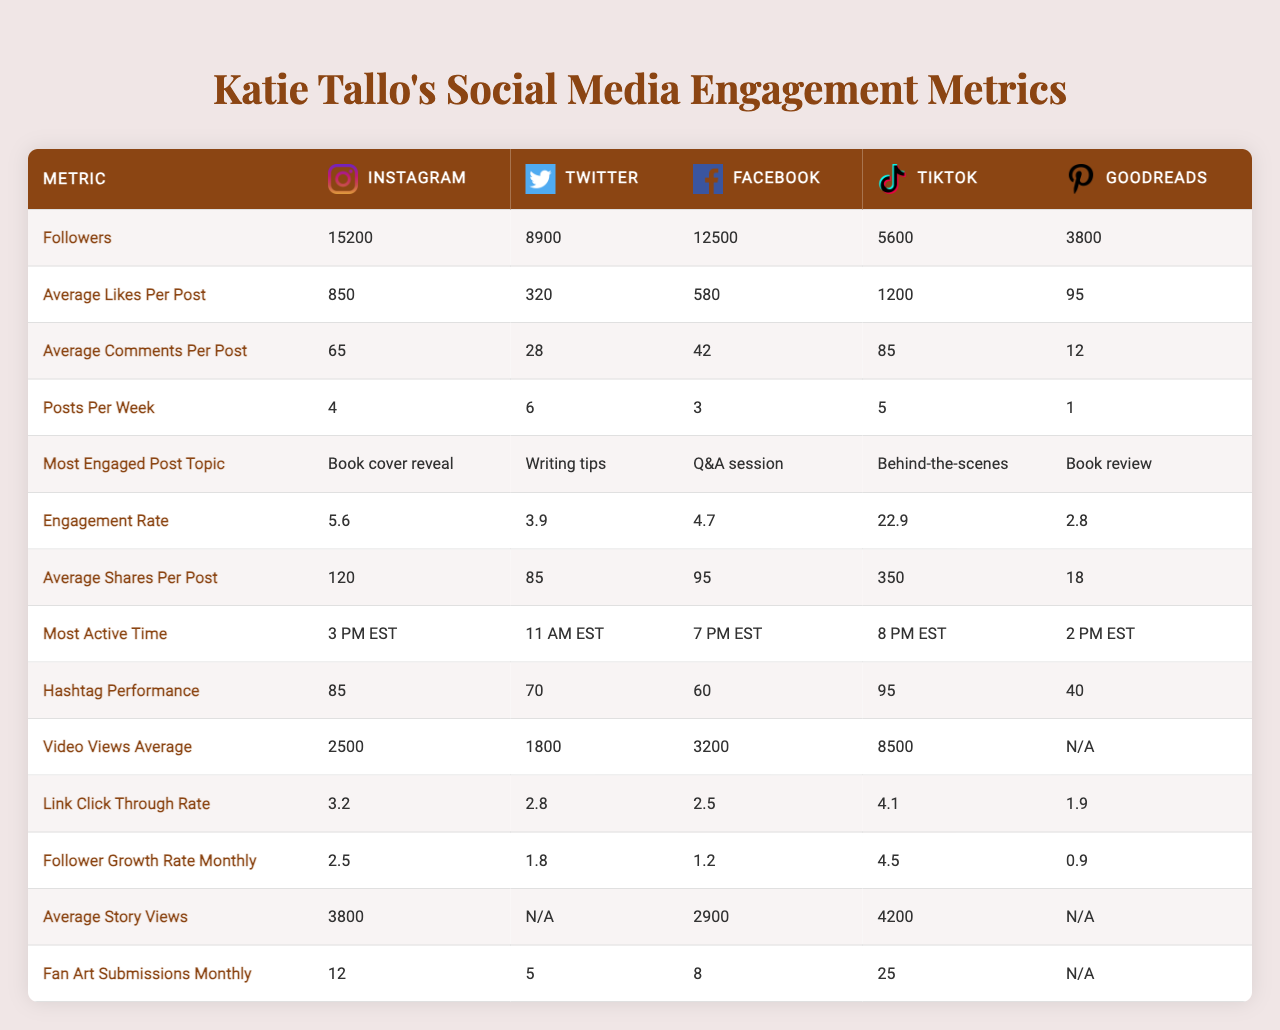What platform has the highest engagement rate? By looking at the engagement rate for each platform, TikTok has the highest engagement rate at 22.9%.
Answer: TikTok What is the average number of likes per post on Twitter? The table states that the average likes per post on Twitter is 320.
Answer: 320 What is the most engaged post topic on Instagram? The table indicates that the most engaged post topic on Instagram is "Book cover reveal."
Answer: Book cover reveal Which platform has the highest average shares per post? Reviewing the average shares per post, TikTok has the highest at 350.
Answer: TikTok What is the difference in followers between Instagram and Facebook? Instagram has 15,200 followers and Facebook has 12,500 followers. The difference is 15,200 - 12,500 = 2,700.
Answer: 2,700 What is the average follower growth rate across all platforms? By summing the monthly growth rates: (2.5 + 1.8 + 1.2 + 4.5 + 0.9 = 12.9) and dividing by 5 (the number of platforms) gives: 12.9 / 5 = 2.58.
Answer: 2.58 Is the average comments per post on TikTok higher than that on Instagram? TikTok's average comments per post is 85, while Instagram's is 65. Since 85 is greater than 65, the statement is true.
Answer: Yes What is the most active time on Twitter? According to the table, the most active time on Twitter is 11 AM EST.
Answer: 11 AM EST If you combine the average likes per post from Instagram and Facebook, what is the total? Adding the average likes for Instagram (850) and Facebook (580) gives: 850 + 580 = 1430.
Answer: 1430 Which social media platform has the lowest follower count? The table shows that Goodreads has the lowest follower count at 3,800.
Answer: Goodreads How does the average story views on TikTok compare to that of Facebook? TikTok has 4,200 average story views while Facebook has 2,900. Since 4,200 is greater than 2,900, TikTok has a higher average story view.
Answer: Higher How many total fan art submissions were made across all platforms? Summing the fan art submissions gives: 12 + 5 + 8 + 25 + 0 = 50, so the total is 50 submissions.
Answer: 50 What platform has the lowest engagement rate? The engagement rate for Goodreads is 2.8%, which is lower than all other platforms listed.
Answer: Goodreads Which platform has the highest average likes per post? TikTok's average likes per post is 1,200, which is the highest among all platforms.
Answer: TikTok 